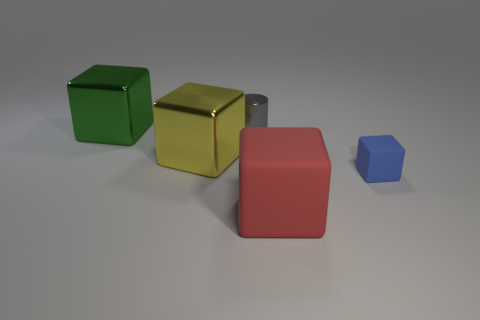Is there another object of the same size as the gray thing?
Offer a very short reply. Yes. Is the shape of the tiny thing that is behind the big green metal cube the same as  the yellow metal object?
Your answer should be very brief. No. Is the shape of the red thing the same as the small metallic thing?
Keep it short and to the point. No. Is there a small blue rubber object that has the same shape as the tiny metal thing?
Give a very brief answer. No. There is a tiny object that is in front of the metal thing that is behind the big green block; what shape is it?
Offer a very short reply. Cube. What is the color of the metal thing that is behind the large green thing?
Provide a succinct answer. Gray. What is the size of the blue object that is the same material as the red thing?
Give a very brief answer. Small. There is a yellow metallic thing that is the same shape as the blue matte thing; what is its size?
Keep it short and to the point. Large. Are any small cubes visible?
Ensure brevity in your answer.  Yes. How many things are objects to the left of the yellow metal object or tiny cylinders?
Keep it short and to the point. 2. 